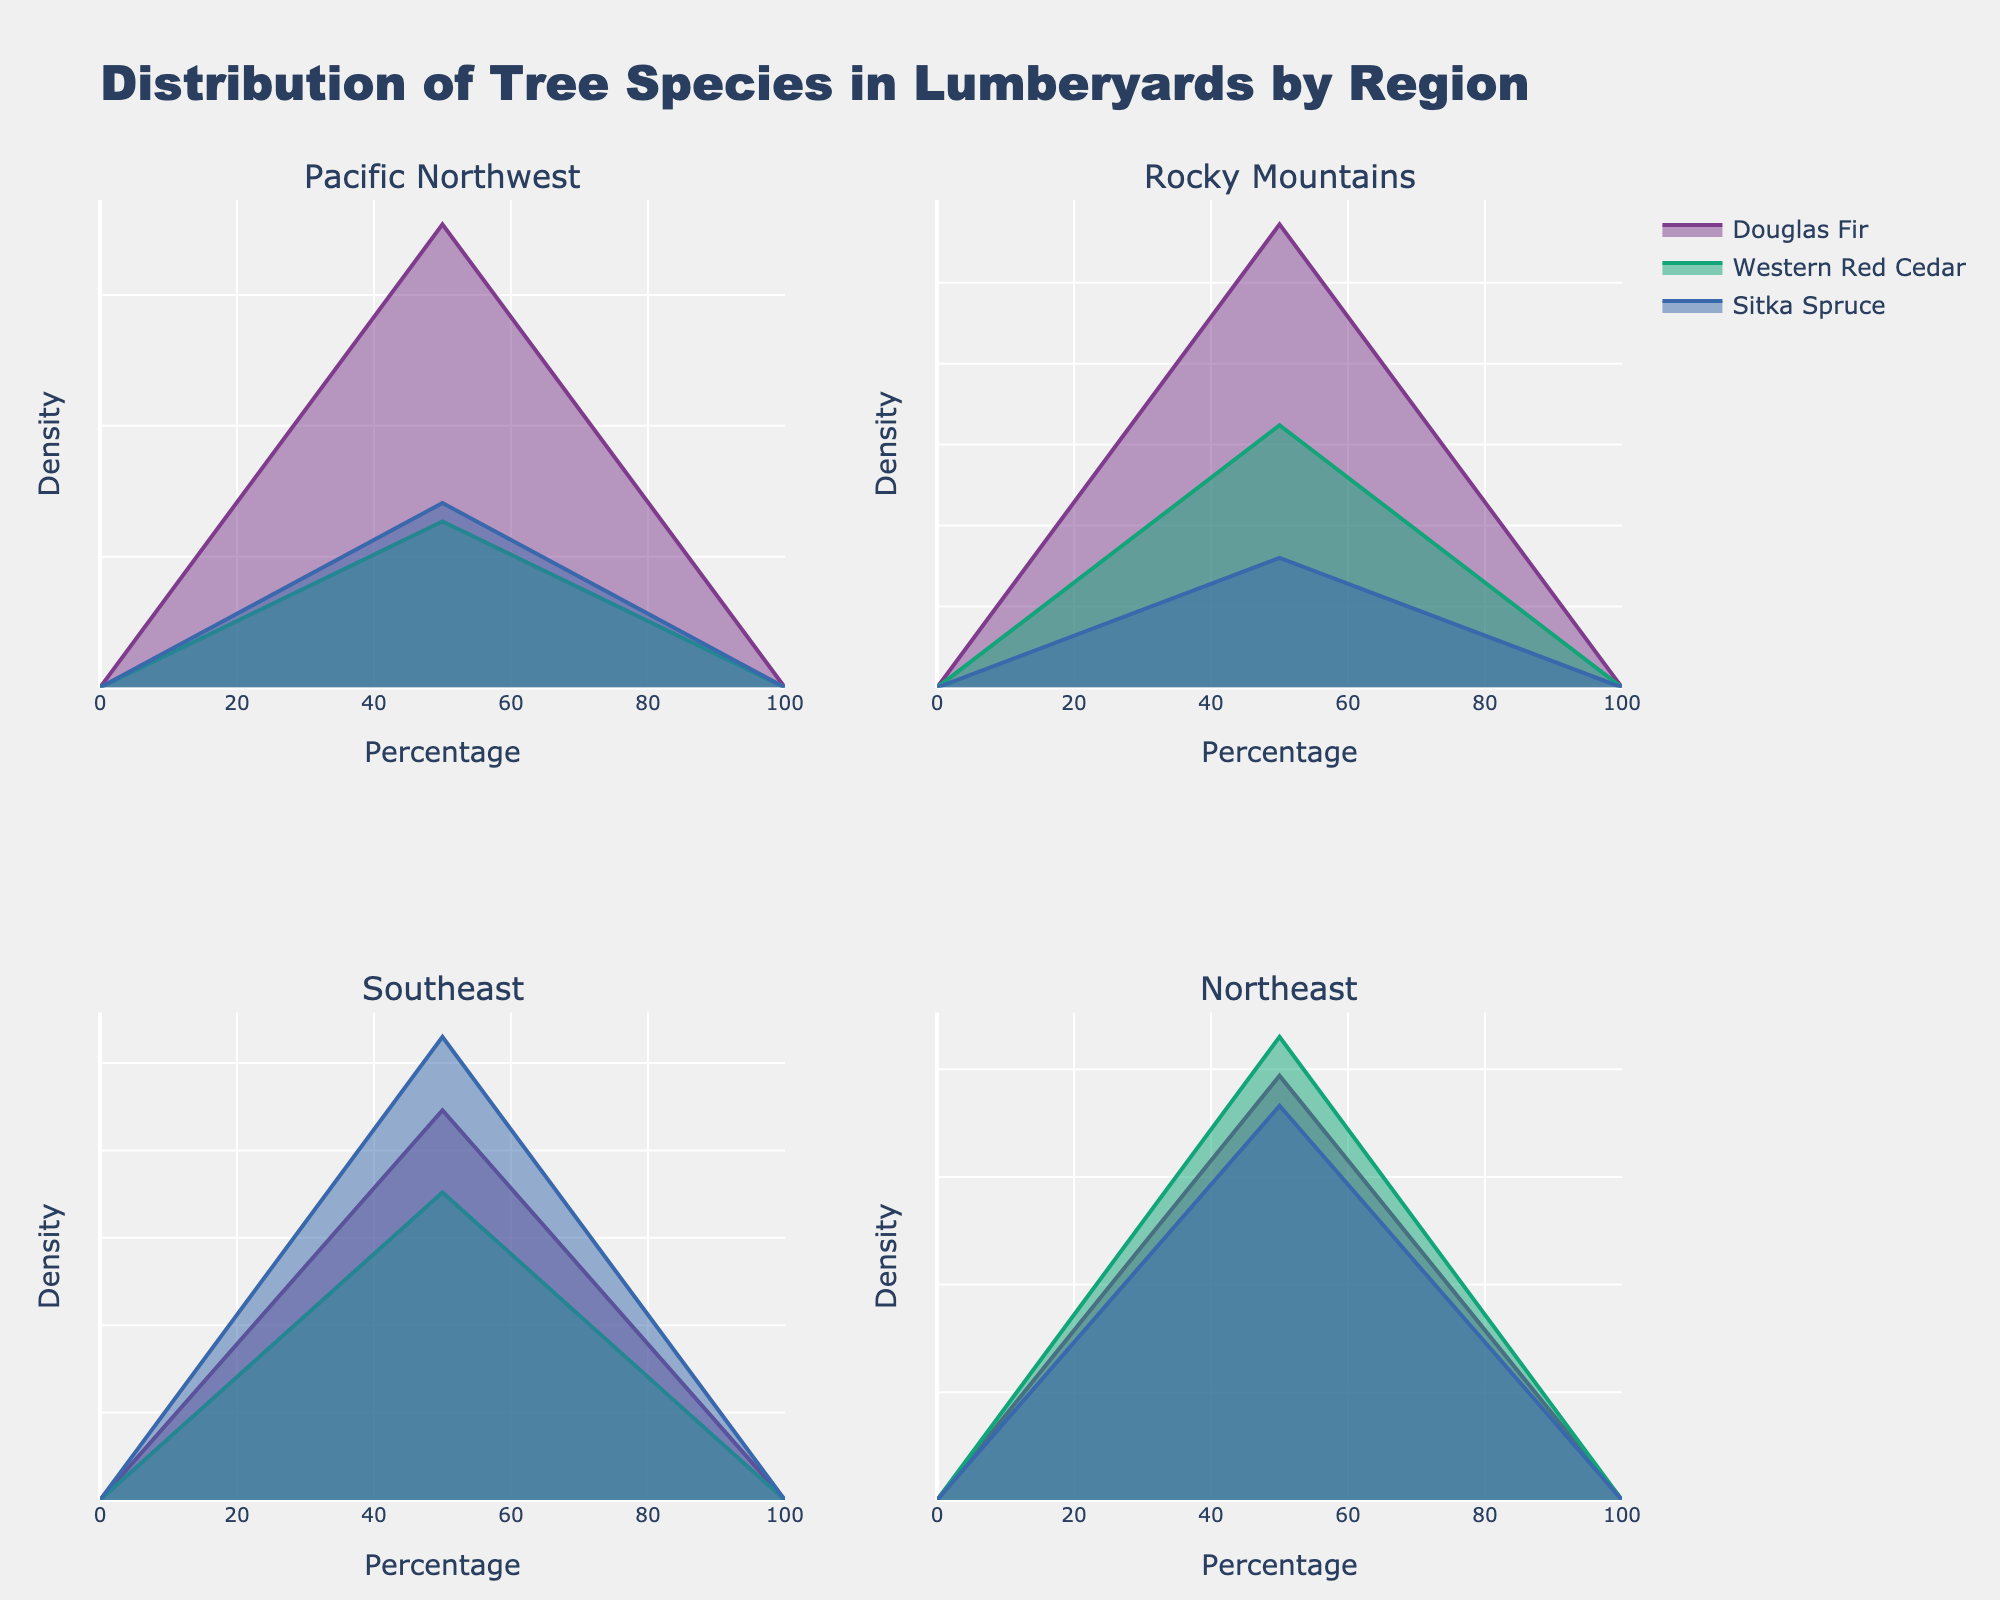How many regions are shown in the plot? The plot has titles for each subplot, representing different regions. By counting the titles, you can determine the number of regions displayed.
Answer: 4 Which tree species has the highest percentage in the Pacific Northwest? Look at the Pacific Northwest subplot and identify the species with the highest peak along the percentage axis.
Answer: Douglas Fir What tree species are present in the Southeast region? Refer to the Southeast subplot and note the labels for the different density lines.
Answer: Yellow Poplar, Sweetgum, Loblolly Pine Compare the percentages of Ponderosa Pine and Lodgepole Pine in the Rocky Mountains. Which has a higher percentage? Look at the Rocky Mountains subplot and compare the peak values for Ponderosa Pine and Lodgepole Pine. Ponderosa Pine has a percentage of 28.6%, and Lodgepole Pine has 16.2%.
Answer: Ponderosa Pine What is the combined percentage of all tree species in the Northeast region? Identify the percentages of Red Maple, White Oak, and Sugar Maple in the Northeast subplot and add them: 19.7 + 21.5 + 18.3 = 59.5%.
Answer: 59.5% Which region has the most varieties of tree species based on the figure? Count the different species labeled in each subplot. The region with the highest count has the most varieties.
Answer: Pacific Northwest Is the percentage of Sitka Spruce greater than that of Sweetgum? Compare their peak values in their respective regions. Sitka Spruce in the Pacific Northwest has 14.1%, and Sweetgum in the Southeast has 17.6%.
Answer: No Which tree species appears in the Rocky Mountains region, but not in the Northeast region? Compare the tree species labels between the Rocky Mountains and Northeast subplots. Engelmann Spruce is in the Rocky Mountains but not in the Northeast.
Answer: Engelmann Spruce 